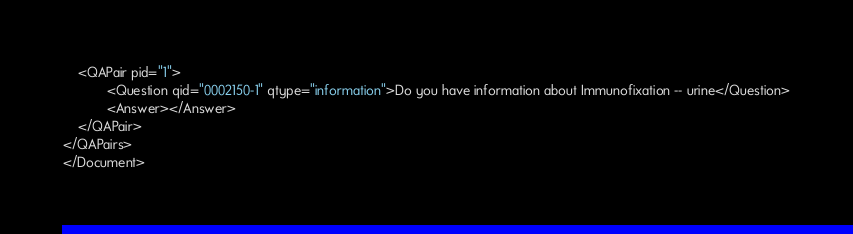<code> <loc_0><loc_0><loc_500><loc_500><_XML_>	<QAPair pid="1">
			<Question qid="0002150-1" qtype="information">Do you have information about Immunofixation -- urine</Question>
			<Answer></Answer>
	</QAPair>
</QAPairs>
</Document>
</code> 